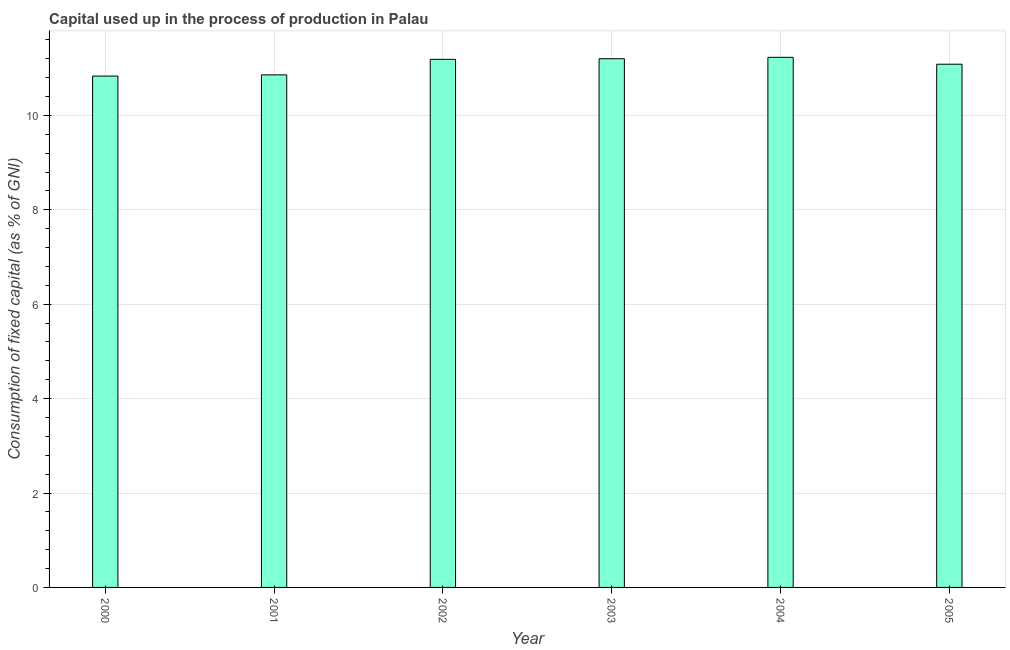Does the graph contain any zero values?
Your answer should be very brief. No. What is the title of the graph?
Ensure brevity in your answer.  Capital used up in the process of production in Palau. What is the label or title of the Y-axis?
Your answer should be very brief. Consumption of fixed capital (as % of GNI). What is the consumption of fixed capital in 2005?
Your response must be concise. 11.08. Across all years, what is the maximum consumption of fixed capital?
Make the answer very short. 11.23. Across all years, what is the minimum consumption of fixed capital?
Your response must be concise. 10.83. In which year was the consumption of fixed capital maximum?
Your answer should be compact. 2004. What is the sum of the consumption of fixed capital?
Offer a terse response. 66.4. What is the difference between the consumption of fixed capital in 2003 and 2005?
Your answer should be compact. 0.12. What is the average consumption of fixed capital per year?
Your answer should be very brief. 11.07. What is the median consumption of fixed capital?
Ensure brevity in your answer.  11.14. In how many years, is the consumption of fixed capital greater than 7.6 %?
Make the answer very short. 6. Do a majority of the years between 2000 and 2005 (inclusive) have consumption of fixed capital greater than 2 %?
Offer a terse response. Yes. Is the difference between the consumption of fixed capital in 2000 and 2005 greater than the difference between any two years?
Offer a terse response. No. What is the difference between the highest and the second highest consumption of fixed capital?
Your response must be concise. 0.03. Is the sum of the consumption of fixed capital in 2002 and 2005 greater than the maximum consumption of fixed capital across all years?
Keep it short and to the point. Yes. What is the difference between two consecutive major ticks on the Y-axis?
Offer a terse response. 2. Are the values on the major ticks of Y-axis written in scientific E-notation?
Provide a succinct answer. No. What is the Consumption of fixed capital (as % of GNI) in 2000?
Make the answer very short. 10.83. What is the Consumption of fixed capital (as % of GNI) in 2001?
Offer a terse response. 10.86. What is the Consumption of fixed capital (as % of GNI) of 2002?
Offer a terse response. 11.19. What is the Consumption of fixed capital (as % of GNI) of 2003?
Your response must be concise. 11.2. What is the Consumption of fixed capital (as % of GNI) of 2004?
Keep it short and to the point. 11.23. What is the Consumption of fixed capital (as % of GNI) of 2005?
Your answer should be very brief. 11.08. What is the difference between the Consumption of fixed capital (as % of GNI) in 2000 and 2001?
Offer a very short reply. -0.03. What is the difference between the Consumption of fixed capital (as % of GNI) in 2000 and 2002?
Offer a terse response. -0.35. What is the difference between the Consumption of fixed capital (as % of GNI) in 2000 and 2003?
Provide a short and direct response. -0.37. What is the difference between the Consumption of fixed capital (as % of GNI) in 2000 and 2004?
Make the answer very short. -0.4. What is the difference between the Consumption of fixed capital (as % of GNI) in 2000 and 2005?
Offer a very short reply. -0.25. What is the difference between the Consumption of fixed capital (as % of GNI) in 2001 and 2002?
Your answer should be compact. -0.33. What is the difference between the Consumption of fixed capital (as % of GNI) in 2001 and 2003?
Offer a very short reply. -0.34. What is the difference between the Consumption of fixed capital (as % of GNI) in 2001 and 2004?
Your answer should be very brief. -0.37. What is the difference between the Consumption of fixed capital (as % of GNI) in 2001 and 2005?
Keep it short and to the point. -0.23. What is the difference between the Consumption of fixed capital (as % of GNI) in 2002 and 2003?
Your answer should be compact. -0.01. What is the difference between the Consumption of fixed capital (as % of GNI) in 2002 and 2004?
Offer a very short reply. -0.04. What is the difference between the Consumption of fixed capital (as % of GNI) in 2002 and 2005?
Your answer should be very brief. 0.1. What is the difference between the Consumption of fixed capital (as % of GNI) in 2003 and 2004?
Offer a terse response. -0.03. What is the difference between the Consumption of fixed capital (as % of GNI) in 2003 and 2005?
Offer a very short reply. 0.12. What is the difference between the Consumption of fixed capital (as % of GNI) in 2004 and 2005?
Your answer should be very brief. 0.15. What is the ratio of the Consumption of fixed capital (as % of GNI) in 2000 to that in 2001?
Your answer should be compact. 1. What is the ratio of the Consumption of fixed capital (as % of GNI) in 2000 to that in 2003?
Provide a succinct answer. 0.97. What is the ratio of the Consumption of fixed capital (as % of GNI) in 2000 to that in 2005?
Provide a succinct answer. 0.98. What is the ratio of the Consumption of fixed capital (as % of GNI) in 2001 to that in 2002?
Provide a succinct answer. 0.97. What is the ratio of the Consumption of fixed capital (as % of GNI) in 2001 to that in 2004?
Make the answer very short. 0.97. What is the ratio of the Consumption of fixed capital (as % of GNI) in 2002 to that in 2004?
Keep it short and to the point. 1. What is the ratio of the Consumption of fixed capital (as % of GNI) in 2003 to that in 2004?
Ensure brevity in your answer.  1. What is the ratio of the Consumption of fixed capital (as % of GNI) in 2003 to that in 2005?
Ensure brevity in your answer.  1.01. 